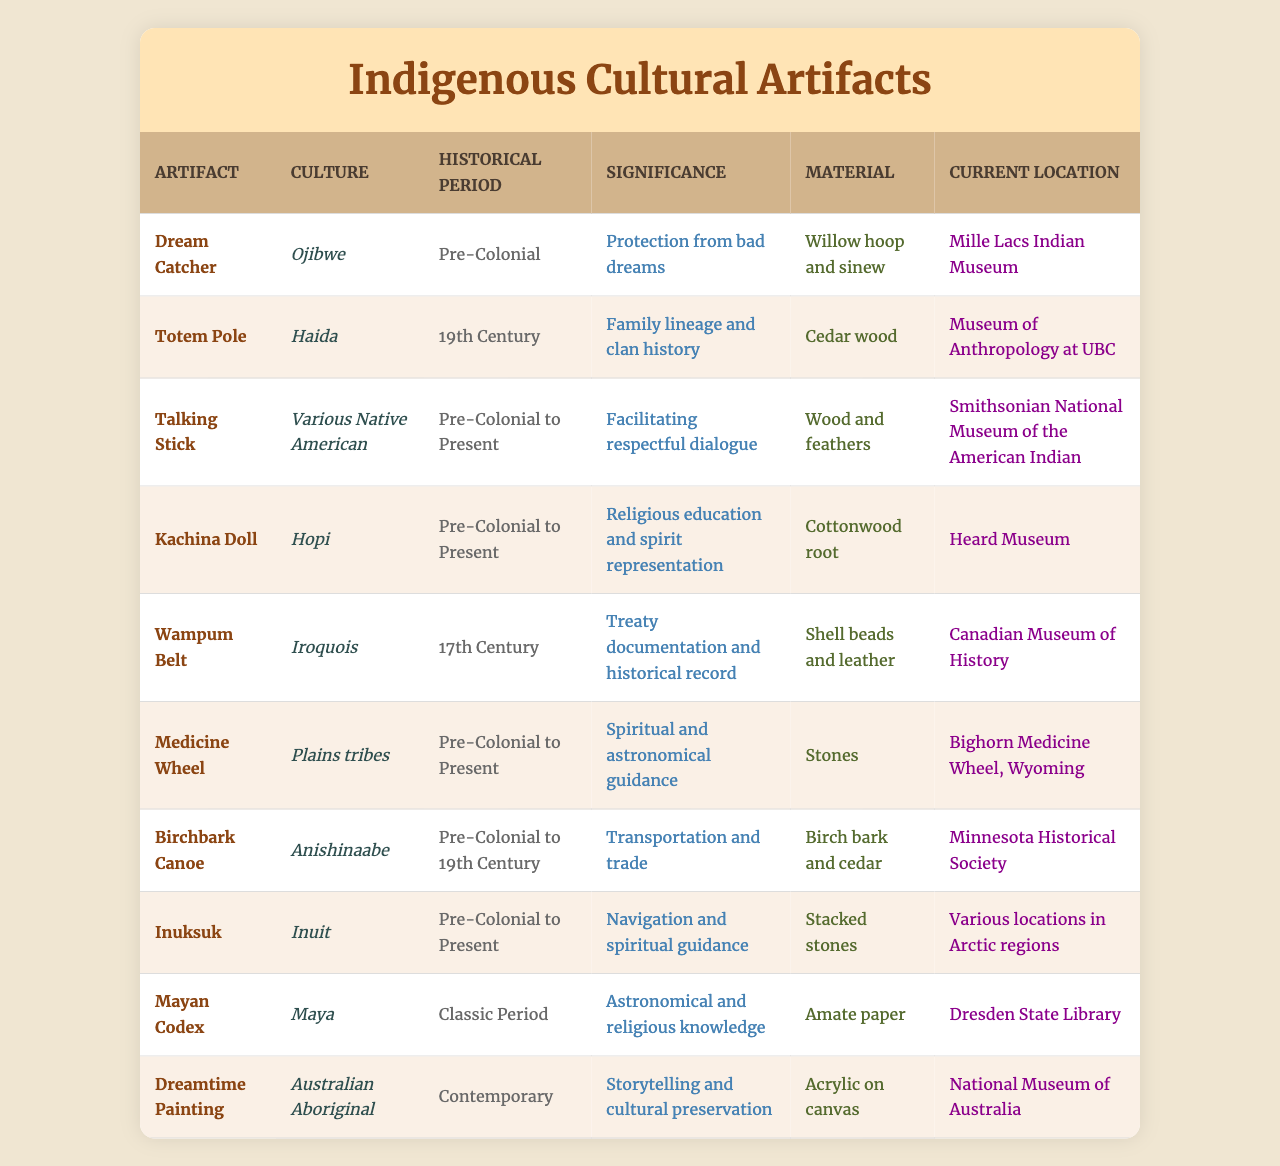What is the historical period of the Dream Catcher? The table lists the Dream Catcher under "Pre-Colonial" in the historical period column.
Answer: Pre-Colonial Which cultural artifact is made of cedar wood? By examining the material column, the Totem Pole is the artifact listed with cedar wood as its material.
Answer: Totem Pole Does the Kachina Doll belong to the Hopi culture? The table specifies that the Kachina Doll is associated with the Hopi culture, confirming this as true.
Answer: Yes How many artifacts in the table are from the Pre-Colonial period? The artifacts listed under "Pre-Colonial" are the Dream Catcher, Talking Stick, Kachina Doll, Medicine Wheel, Birchbark Canoe, and Inuksuk, totaling six artifacts.
Answer: 6 What is the significance of the Wampum Belt? The table indicates that the Wampum Belt serves as a treaty documentation and historical record, which is its significance.
Answer: Treaty documentation and historical record Which artifact has the current location listed as the Smithsonian National Museum of the American Indian? The Talking Stick is recognized in the table for having the Smithsonian National Museum of the American Indian as its current location.
Answer: Talking Stick Is the Dreamtime Painting associated with storytelling? The table shows that the Dreamtime Painting is significant for storytelling and cultural preservation, confirming the association.
Answer: Yes How many different cultures are represented in the artifacts listed? The artifacts represent Ojibwe, Haida, various Native American, Hopi, Iroquois, Plains tribes, Anishinaabe, Inuit, Maya, and Australian Aboriginal, totaling ten distinct cultures.
Answer: 10 Can you name the artifact that is associated with spiritual guidance and is made from stacked stones? The Inuksuk is indicated in the table as being made from stacked stones and associated with navigation and spiritual guidance.
Answer: Inuksuk What materials are used to create the Talking Stick? According to the table, the Talking Stick is made of wood and feathers, which are listed in the materials column.
Answer: Wood and feathers 